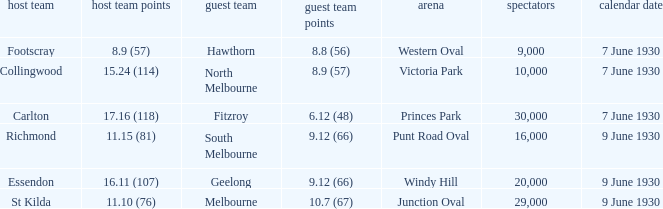What is the away team that scored 9.12 (66) at Windy Hill? Geelong. 